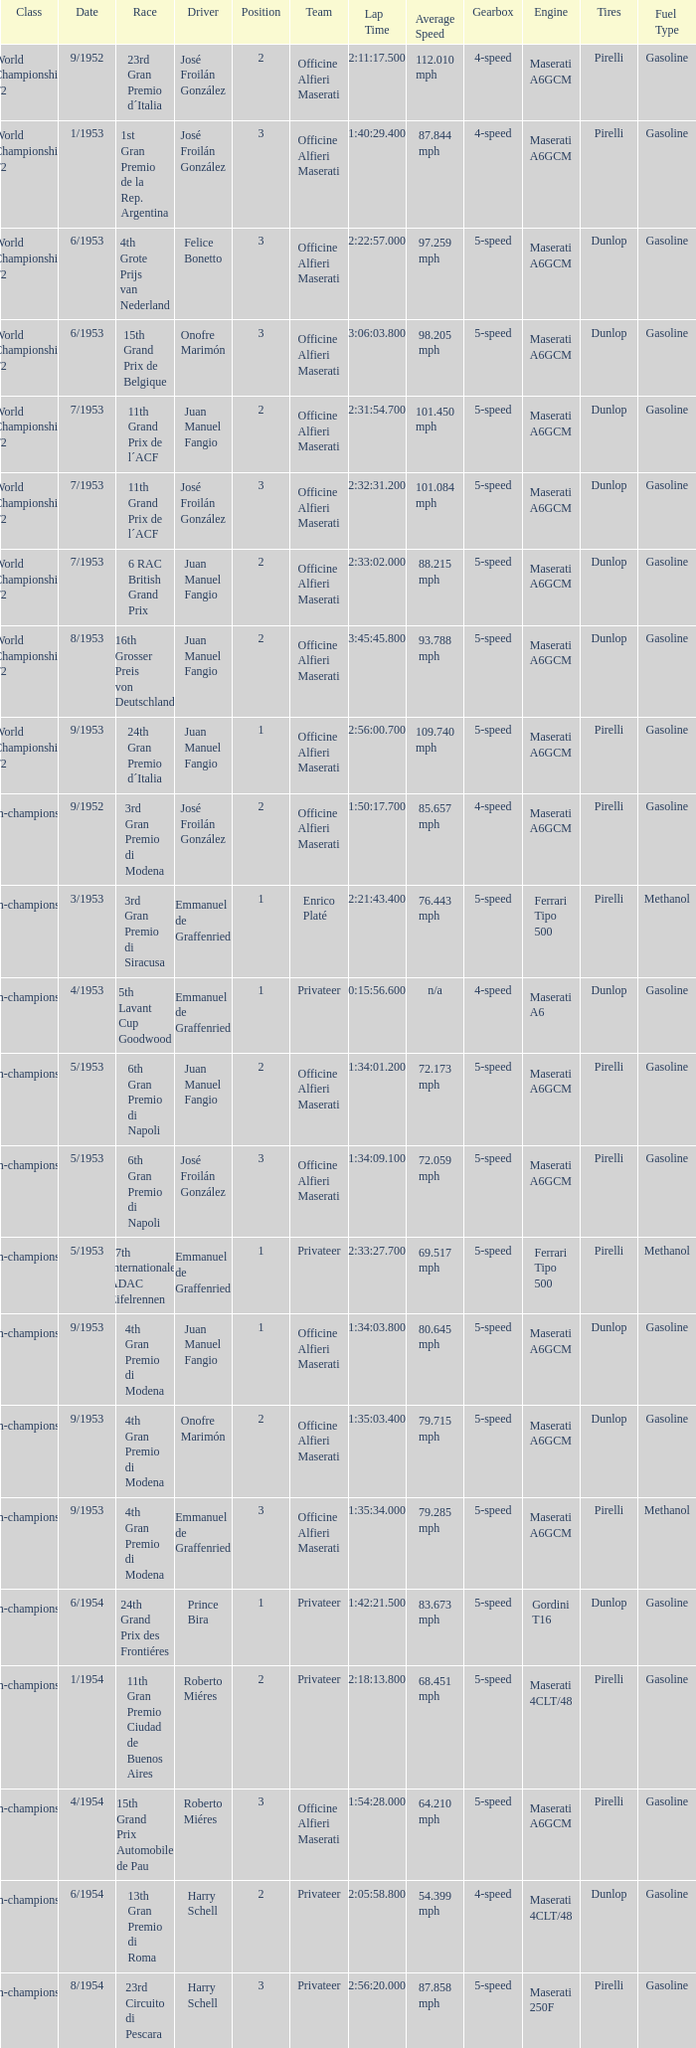What driver has a team of officine alfieri maserati and belongs to the class of non-championship f2 and has a position of 2, as well as a date of 9/1952? José Froilán González. Give me the full table as a dictionary. {'header': ['Class', 'Date', 'Race', 'Driver', 'Position', 'Team', 'Lap Time', 'Average Speed', 'Gearbox', 'Engine', 'Tires', 'Fuel Type'], 'rows': [['World Championship F2', '9/1952', '23rd Gran Premio d´Italia', 'José Froilán González', '2', 'Officine Alfieri Maserati', '2:11:17.500', '112.010 mph', '4-speed', 'Maserati A6GCM', 'Pirelli', 'Gasoline'], ['World Championship F2', '1/1953', '1st Gran Premio de la Rep. Argentina', 'José Froilán González', '3', 'Officine Alfieri Maserati', '1:40:29.400', '87.844 mph', '4-speed', 'Maserati A6GCM', 'Pirelli', 'Gasoline'], ['World Championship F2', '6/1953', '4th Grote Prijs van Nederland', 'Felice Bonetto', '3', 'Officine Alfieri Maserati', '2:22:57.000', '97.259 mph', '5-speed', 'Maserati A6GCM', 'Dunlop', 'Gasoline'], ['World Championship F2', '6/1953', '15th Grand Prix de Belgique', 'Onofre Marimón', '3', 'Officine Alfieri Maserati', '3:06:03.800', '98.205 mph', '5-speed', 'Maserati A6GCM', 'Dunlop', 'Gasoline'], ['World Championship F2', '7/1953', '11th Grand Prix de l´ACF', 'Juan Manuel Fangio', '2', 'Officine Alfieri Maserati', '2:31:54.700', '101.450 mph', '5-speed', 'Maserati A6GCM', 'Dunlop', 'Gasoline'], ['World Championship F2', '7/1953', '11th Grand Prix de l´ACF', 'José Froilán González', '3', 'Officine Alfieri Maserati', '2:32:31.200', '101.084 mph', '5-speed', 'Maserati A6GCM', 'Dunlop', 'Gasoline'], ['World Championship F2', '7/1953', '6 RAC British Grand Prix', 'Juan Manuel Fangio', '2', 'Officine Alfieri Maserati', '2:33:02.000', '88.215 mph', '5-speed', 'Maserati A6GCM', 'Dunlop', 'Gasoline'], ['World Championship F2', '8/1953', '16th Grosser Preis von Deutschland', 'Juan Manuel Fangio', '2', 'Officine Alfieri Maserati', '3:45:45.800', '93.788 mph', '5-speed', 'Maserati A6GCM', 'Dunlop', 'Gasoline'], ['World Championship F2', '9/1953', '24th Gran Premio d´Italia', 'Juan Manuel Fangio', '1', 'Officine Alfieri Maserati', '2:56:00.700', '109.740 mph', '5-speed', 'Maserati A6GCM', 'Pirelli', 'Gasoline'], ['Non-championship F2', '9/1952', '3rd Gran Premio di Modena', 'José Froilán González', '2', 'Officine Alfieri Maserati', '1:50:17.700', '85.657 mph', '4-speed', 'Maserati A6GCM', 'Pirelli', 'Gasoline'], ['Non-championship F2', '3/1953', '3rd Gran Premio di Siracusa', 'Emmanuel de Graffenried', '1', 'Enrico Platé', '2:21:43.400', '76.443 mph', '5-speed', 'Ferrari Tipo 500', 'Pirelli', 'Methanol'], ['Non-championship F2', '4/1953', '5th Lavant Cup Goodwood', 'Emmanuel de Graffenried', '1', 'Privateer', '0:15:56.600', 'n/a', '4-speed', 'Maserati A6', 'Dunlop', 'Gasoline'], ['Non-championship F2', '5/1953', '6th Gran Premio di Napoli', 'Juan Manuel Fangio', '2', 'Officine Alfieri Maserati', '1:34:01.200', '72.173 mph', '5-speed', 'Maserati A6GCM', 'Pirelli', 'Gasoline'], ['Non-championship F2', '5/1953', '6th Gran Premio di Napoli', 'José Froilán González', '3', 'Officine Alfieri Maserati', '1:34:09.100', '72.059 mph', '5-speed', 'Maserati A6GCM', 'Pirelli', 'Gasoline'], ['Non-championship F2', '5/1953', '17th Internationales ADAC Eifelrennen', 'Emmanuel de Graffenried', '1', 'Privateer', '2:33:27.700', '69.517 mph', '5-speed', 'Ferrari Tipo 500', 'Pirelli', 'Methanol'], ['Non-championship F2', '9/1953', '4th Gran Premio di Modena', 'Juan Manuel Fangio', '1', 'Officine Alfieri Maserati', '1:34:03.800', '80.645 mph', '5-speed', 'Maserati A6GCM', 'Dunlop', 'Gasoline'], ['Non-championship F2', '9/1953', '4th Gran Premio di Modena', 'Onofre Marimón', '2', 'Officine Alfieri Maserati', '1:35:03.400', '79.715 mph', '5-speed', 'Maserati A6GCM', 'Dunlop', 'Gasoline'], ['Non-championship F2', '9/1953', '4th Gran Premio di Modena', 'Emmanuel de Graffenried', '3', 'Officine Alfieri Maserati', '1:35:34.000', '79.285 mph', '5-speed', 'Maserati A6GCM', 'Pirelli', 'Methanol'], ['(Non-championship) F2', '6/1954', '24th Grand Prix des Frontiéres', 'Prince Bira', '1', 'Privateer', '1:42:21.500', '83.673 mph', '5-speed', 'Gordini T16', 'Dunlop', 'Gasoline'], ['Non-championship F1', '1/1954', '11th Gran Premio Ciudad de Buenos Aires', 'Roberto Miéres', '2', 'Privateer', '2:18:13.800', '68.451 mph', '5-speed', 'Maserati 4CLT/48', 'Pirelli', 'Gasoline'], ['Non-championship F1', '4/1954', '15th Grand Prix Automobile de Pau', 'Roberto Miéres', '3', 'Officine Alfieri Maserati', '1:54:28.000', '64.210 mph', '5-speed', 'Maserati A6GCM', 'Pirelli', 'Gasoline'], ['Non-championship F1', '6/1954', '13th Gran Premio di Roma', 'Harry Schell', '2', 'Privateer', '2:05:58.800', '54.399 mph', '4-speed', 'Maserati 4CLT/48', 'Dunlop', 'Gasoline'], ['Non-championship F1', '8/1954', '23rd Circuito di Pescara', 'Harry Schell', '3', 'Privateer', '2:56:20.000', '87.858 mph', '5-speed', 'Maserati 250F', 'Pirelli', 'Gasoline']]} 